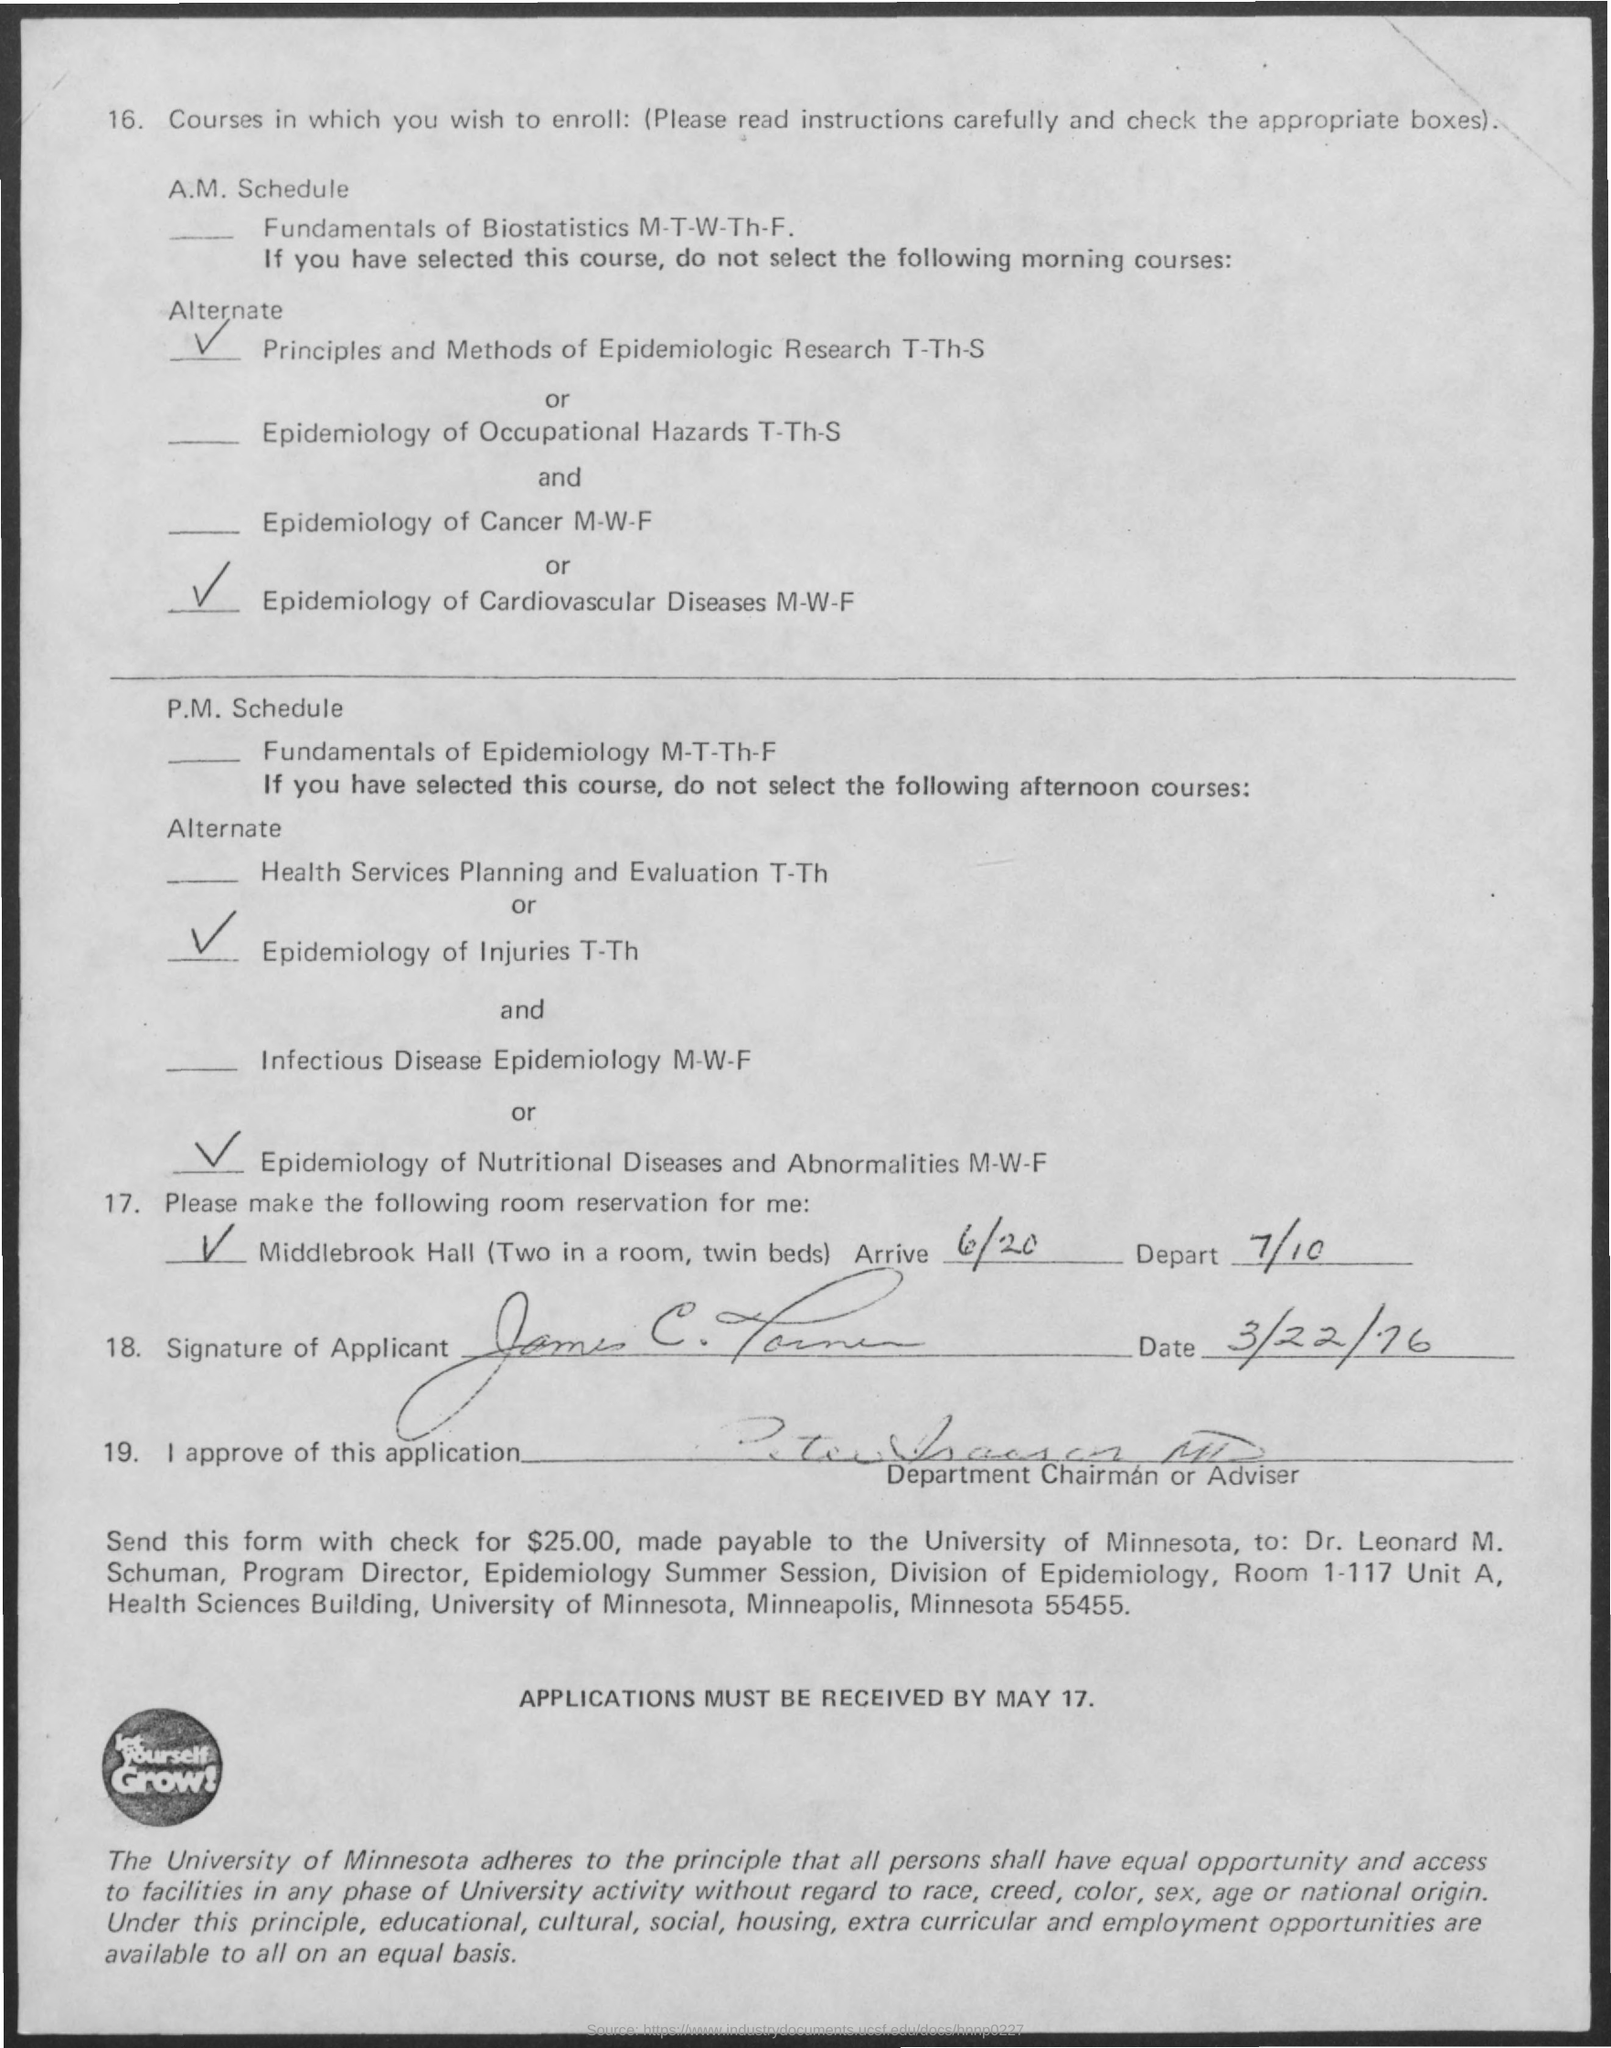Highlight a few significant elements in this photo. The application receipt date is May 17th. On March 22, 1976, the applicant signed. 